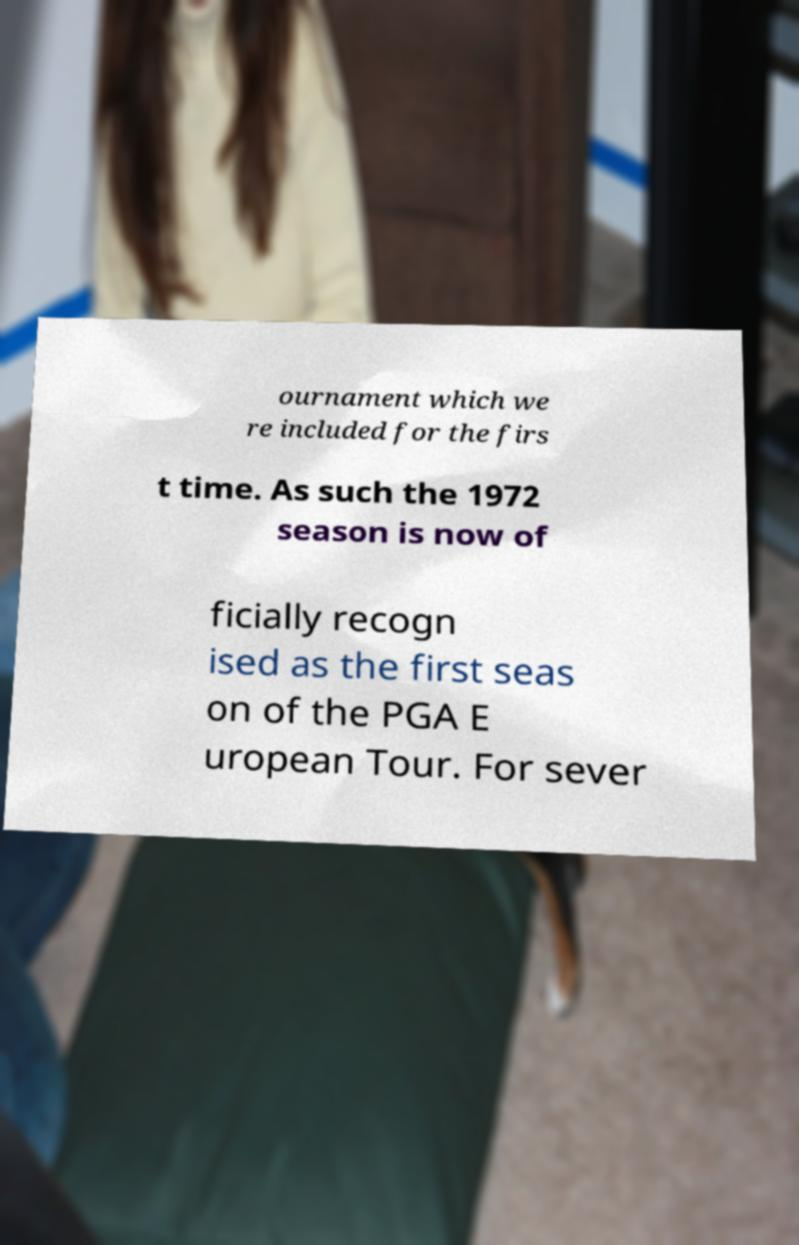Please read and relay the text visible in this image. What does it say? ournament which we re included for the firs t time. As such the 1972 season is now of ficially recogn ised as the first seas on of the PGA E uropean Tour. For sever 